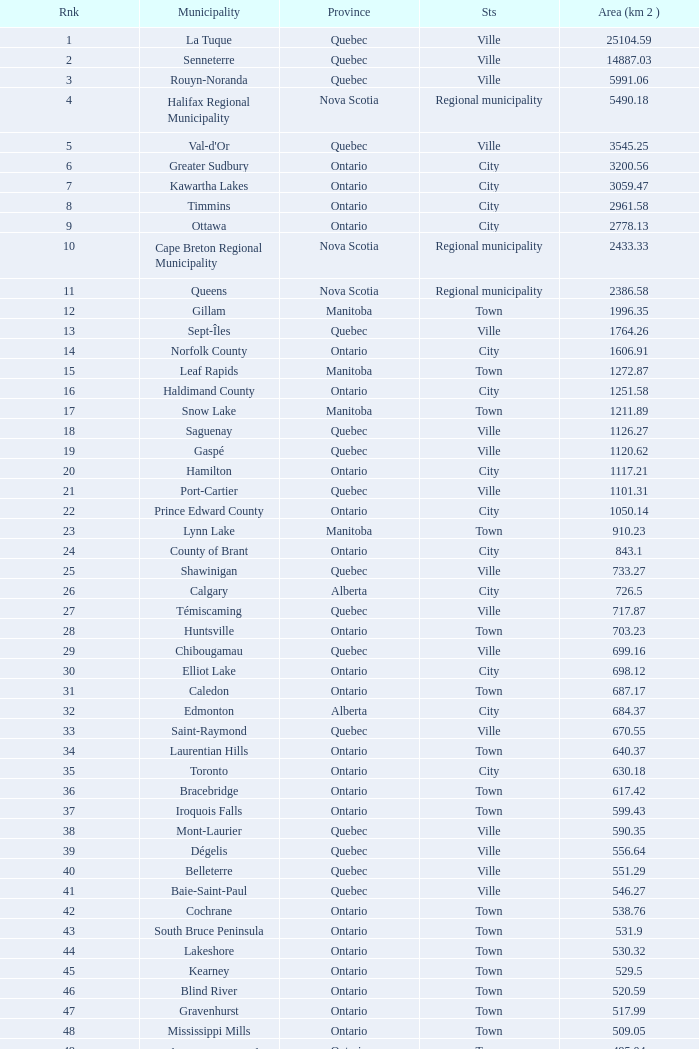What's the total of Rank that has an Area (KM 2) of 1050.14? 22.0. 